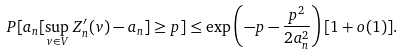<formula> <loc_0><loc_0><loc_500><loc_500>P [ a _ { n } [ \sup _ { v \in V } Z _ { n } ^ { \prime } ( v ) - a _ { n } ] \geq p ] \leq \exp \left ( - p - \frac { p ^ { 2 } } { 2 a _ { n } ^ { 2 } } \right ) [ 1 + o ( 1 ) ] .</formula> 